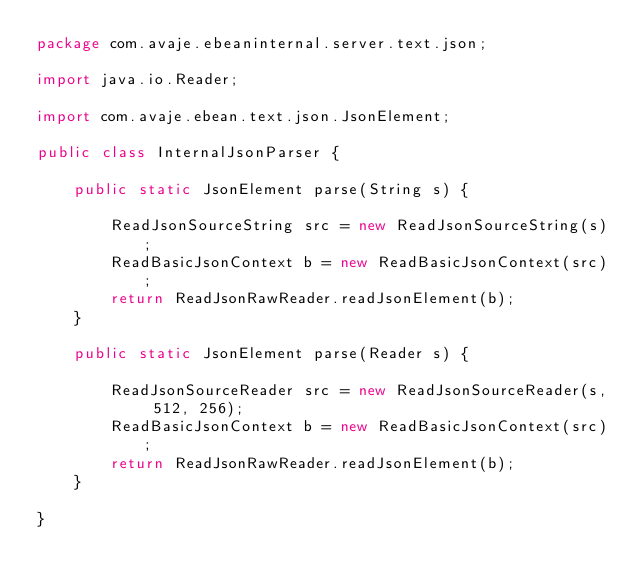Convert code to text. <code><loc_0><loc_0><loc_500><loc_500><_Java_>package com.avaje.ebeaninternal.server.text.json;

import java.io.Reader;

import com.avaje.ebean.text.json.JsonElement;

public class InternalJsonParser {

	public static JsonElement parse(String s) {
		
		ReadJsonSourceString src = new ReadJsonSourceString(s);
		ReadBasicJsonContext b = new ReadBasicJsonContext(src);
		return ReadJsonRawReader.readJsonElement(b);
	}

	public static JsonElement parse(Reader s) {
		
		ReadJsonSourceReader src = new ReadJsonSourceReader(s, 512, 256);
		ReadBasicJsonContext b = new ReadBasicJsonContext(src);
		return ReadJsonRawReader.readJsonElement(b);
	}

}
</code> 